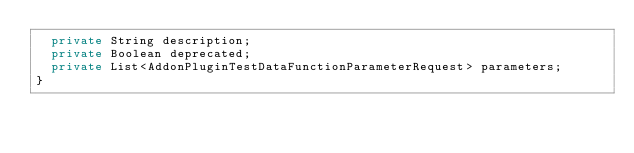Convert code to text. <code><loc_0><loc_0><loc_500><loc_500><_Java_>  private String description;
  private Boolean deprecated;
  private List<AddonPluginTestDataFunctionParameterRequest> parameters;
}
</code> 